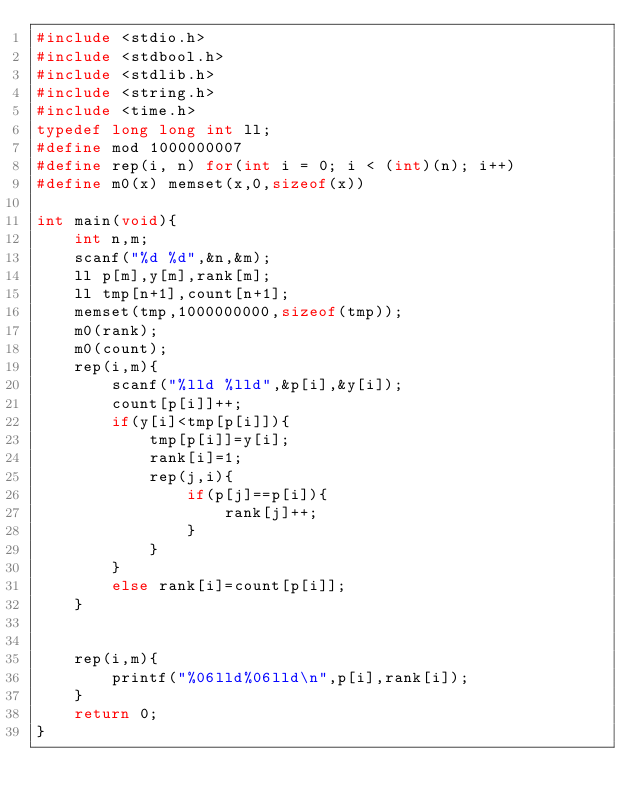Convert code to text. <code><loc_0><loc_0><loc_500><loc_500><_C_>#include <stdio.h>
#include <stdbool.h>
#include <stdlib.h>
#include <string.h>
#include <time.h>
typedef long long int ll;
#define mod 1000000007
#define rep(i, n) for(int i = 0; i < (int)(n); i++)
#define m0(x) memset(x,0,sizeof(x))

int main(void){
	int n,m;
	scanf("%d %d",&n,&m);
	ll p[m],y[m],rank[m];
	ll tmp[n+1],count[n+1];
	memset(tmp,1000000000,sizeof(tmp));
	m0(rank);
	m0(count);
	rep(i,m){
		scanf("%lld %lld",&p[i],&y[i]);
		count[p[i]]++;
		if(y[i]<tmp[p[i]]){
			tmp[p[i]]=y[i];
			rank[i]=1;
			rep(j,i){
				if(p[j]==p[i]){
					rank[j]++;
				}
			}
		}
		else rank[i]=count[p[i]];
	}


	rep(i,m){
		printf("%06lld%06lld\n",p[i],rank[i]);
	}
	return 0;
}</code> 